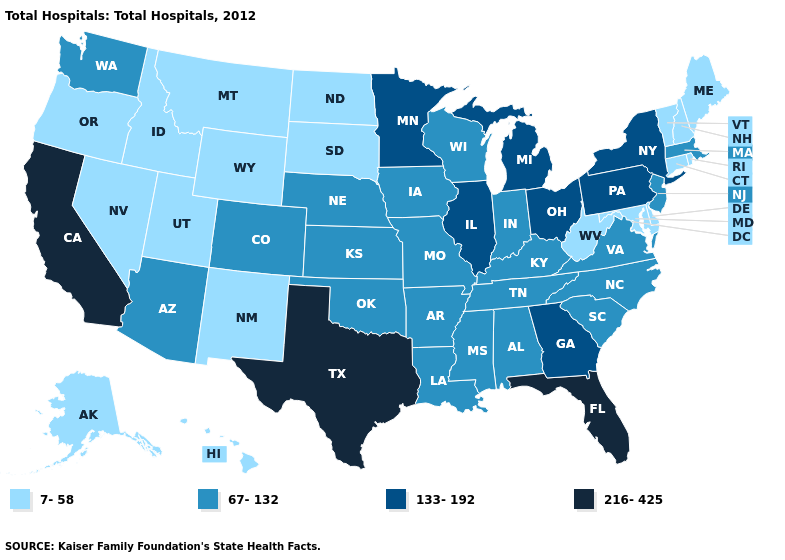Among the states that border Idaho , which have the highest value?
Short answer required. Washington. What is the highest value in the USA?
Concise answer only. 216-425. What is the lowest value in the USA?
Answer briefly. 7-58. What is the lowest value in the USA?
Quick response, please. 7-58. Does the map have missing data?
Quick response, please. No. Which states have the highest value in the USA?
Be succinct. California, Florida, Texas. Name the states that have a value in the range 67-132?
Give a very brief answer. Alabama, Arizona, Arkansas, Colorado, Indiana, Iowa, Kansas, Kentucky, Louisiana, Massachusetts, Mississippi, Missouri, Nebraska, New Jersey, North Carolina, Oklahoma, South Carolina, Tennessee, Virginia, Washington, Wisconsin. Does Virginia have the highest value in the USA?
Concise answer only. No. Name the states that have a value in the range 67-132?
Answer briefly. Alabama, Arizona, Arkansas, Colorado, Indiana, Iowa, Kansas, Kentucky, Louisiana, Massachusetts, Mississippi, Missouri, Nebraska, New Jersey, North Carolina, Oklahoma, South Carolina, Tennessee, Virginia, Washington, Wisconsin. How many symbols are there in the legend?
Answer briefly. 4. Does New York have the highest value in the Northeast?
Quick response, please. Yes. Name the states that have a value in the range 216-425?
Be succinct. California, Florida, Texas. What is the highest value in the USA?
Concise answer only. 216-425. What is the value of Pennsylvania?
Answer briefly. 133-192. What is the lowest value in the South?
Short answer required. 7-58. 